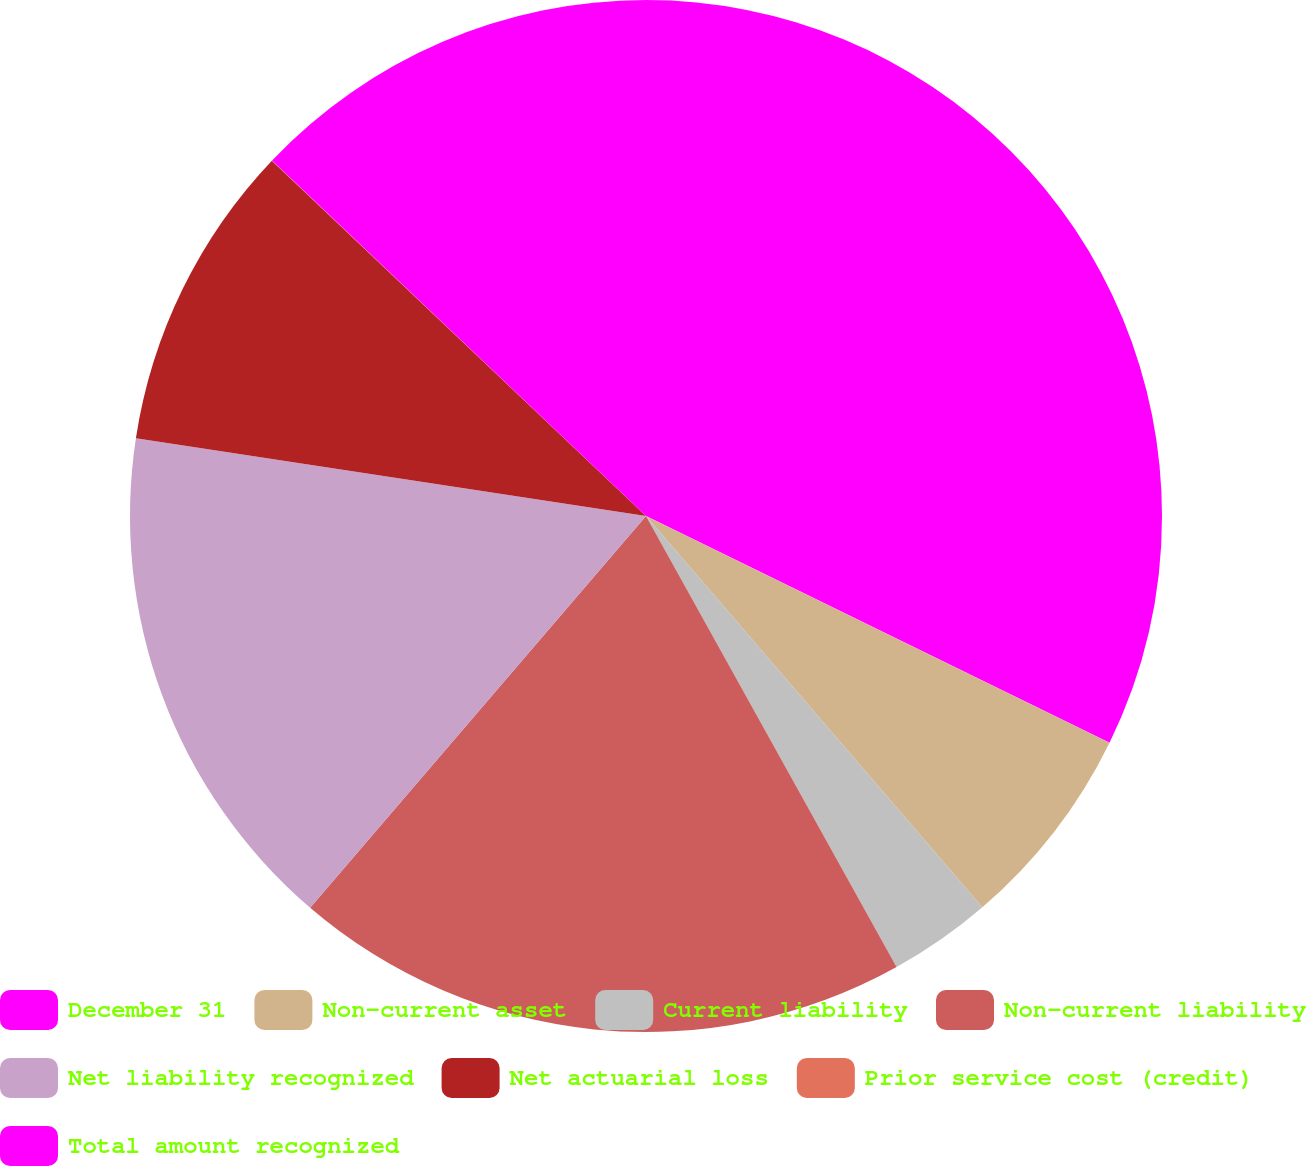Convert chart. <chart><loc_0><loc_0><loc_500><loc_500><pie_chart><fcel>December 31<fcel>Non-current asset<fcel>Current liability<fcel>Non-current liability<fcel>Net liability recognized<fcel>Net actuarial loss<fcel>Prior service cost (credit)<fcel>Total amount recognized<nl><fcel>32.24%<fcel>6.46%<fcel>3.23%<fcel>19.35%<fcel>16.13%<fcel>9.68%<fcel>0.01%<fcel>12.9%<nl></chart> 